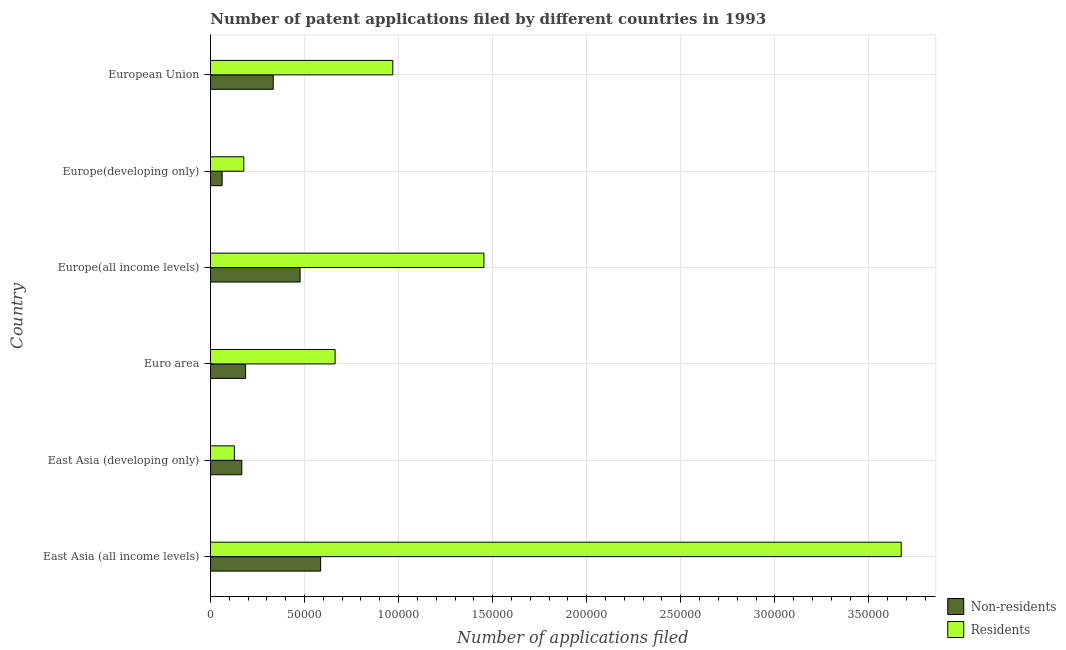How many groups of bars are there?
Ensure brevity in your answer.  6. Are the number of bars on each tick of the Y-axis equal?
Your answer should be very brief. Yes. How many bars are there on the 2nd tick from the top?
Provide a short and direct response. 2. In how many cases, is the number of bars for a given country not equal to the number of legend labels?
Your response must be concise. 0. What is the number of patent applications by non residents in Europe(developing only)?
Your answer should be very brief. 6206. Across all countries, what is the maximum number of patent applications by residents?
Offer a very short reply. 3.67e+05. Across all countries, what is the minimum number of patent applications by residents?
Your response must be concise. 1.27e+04. In which country was the number of patent applications by non residents maximum?
Your response must be concise. East Asia (all income levels). In which country was the number of patent applications by residents minimum?
Offer a very short reply. East Asia (developing only). What is the total number of patent applications by non residents in the graph?
Offer a very short reply. 1.81e+05. What is the difference between the number of patent applications by residents in East Asia (all income levels) and that in Euro area?
Your response must be concise. 3.01e+05. What is the difference between the number of patent applications by residents in East Asia (all income levels) and the number of patent applications by non residents in East Asia (developing only)?
Your response must be concise. 3.51e+05. What is the average number of patent applications by residents per country?
Make the answer very short. 1.18e+05. What is the difference between the number of patent applications by residents and number of patent applications by non residents in Europe(all income levels)?
Your answer should be very brief. 9.77e+04. In how many countries, is the number of patent applications by non residents greater than 360000 ?
Provide a short and direct response. 0. What is the ratio of the number of patent applications by residents in Euro area to that in Europe(all income levels)?
Offer a terse response. 0.46. Is the number of patent applications by residents in East Asia (developing only) less than that in Euro area?
Your answer should be compact. Yes. Is the difference between the number of patent applications by non residents in East Asia (all income levels) and European Union greater than the difference between the number of patent applications by residents in East Asia (all income levels) and European Union?
Offer a terse response. No. What is the difference between the highest and the second highest number of patent applications by residents?
Provide a succinct answer. 2.22e+05. What is the difference between the highest and the lowest number of patent applications by residents?
Provide a short and direct response. 3.54e+05. In how many countries, is the number of patent applications by residents greater than the average number of patent applications by residents taken over all countries?
Offer a terse response. 2. What does the 1st bar from the top in East Asia (all income levels) represents?
Ensure brevity in your answer.  Residents. What does the 2nd bar from the bottom in East Asia (developing only) represents?
Provide a short and direct response. Residents. How many bars are there?
Offer a terse response. 12. How many countries are there in the graph?
Offer a very short reply. 6. What is the difference between two consecutive major ticks on the X-axis?
Give a very brief answer. 5.00e+04. Does the graph contain any zero values?
Your response must be concise. No. Does the graph contain grids?
Provide a short and direct response. Yes. How many legend labels are there?
Your answer should be very brief. 2. What is the title of the graph?
Make the answer very short. Number of patent applications filed by different countries in 1993. Does "US$" appear as one of the legend labels in the graph?
Offer a very short reply. No. What is the label or title of the X-axis?
Provide a short and direct response. Number of applications filed. What is the Number of applications filed of Non-residents in East Asia (all income levels)?
Offer a very short reply. 5.86e+04. What is the Number of applications filed of Residents in East Asia (all income levels)?
Provide a short and direct response. 3.67e+05. What is the Number of applications filed in Non-residents in East Asia (developing only)?
Your response must be concise. 1.67e+04. What is the Number of applications filed in Residents in East Asia (developing only)?
Ensure brevity in your answer.  1.27e+04. What is the Number of applications filed of Non-residents in Euro area?
Offer a terse response. 1.87e+04. What is the Number of applications filed in Residents in Euro area?
Offer a terse response. 6.63e+04. What is the Number of applications filed of Non-residents in Europe(all income levels)?
Keep it short and to the point. 4.76e+04. What is the Number of applications filed of Residents in Europe(all income levels)?
Your response must be concise. 1.45e+05. What is the Number of applications filed in Non-residents in Europe(developing only)?
Your response must be concise. 6206. What is the Number of applications filed of Residents in Europe(developing only)?
Offer a very short reply. 1.77e+04. What is the Number of applications filed in Non-residents in European Union?
Your answer should be compact. 3.34e+04. What is the Number of applications filed in Residents in European Union?
Your answer should be very brief. 9.69e+04. Across all countries, what is the maximum Number of applications filed in Non-residents?
Offer a very short reply. 5.86e+04. Across all countries, what is the maximum Number of applications filed of Residents?
Give a very brief answer. 3.67e+05. Across all countries, what is the minimum Number of applications filed of Non-residents?
Make the answer very short. 6206. Across all countries, what is the minimum Number of applications filed in Residents?
Your answer should be compact. 1.27e+04. What is the total Number of applications filed in Non-residents in the graph?
Provide a short and direct response. 1.81e+05. What is the total Number of applications filed of Residents in the graph?
Your response must be concise. 7.06e+05. What is the difference between the Number of applications filed of Non-residents in East Asia (all income levels) and that in East Asia (developing only)?
Your answer should be compact. 4.19e+04. What is the difference between the Number of applications filed of Residents in East Asia (all income levels) and that in East Asia (developing only)?
Give a very brief answer. 3.54e+05. What is the difference between the Number of applications filed in Non-residents in East Asia (all income levels) and that in Euro area?
Your response must be concise. 3.99e+04. What is the difference between the Number of applications filed in Residents in East Asia (all income levels) and that in Euro area?
Give a very brief answer. 3.01e+05. What is the difference between the Number of applications filed in Non-residents in East Asia (all income levels) and that in Europe(all income levels)?
Ensure brevity in your answer.  1.09e+04. What is the difference between the Number of applications filed in Residents in East Asia (all income levels) and that in Europe(all income levels)?
Offer a very short reply. 2.22e+05. What is the difference between the Number of applications filed of Non-residents in East Asia (all income levels) and that in Europe(developing only)?
Your answer should be compact. 5.24e+04. What is the difference between the Number of applications filed of Residents in East Asia (all income levels) and that in Europe(developing only)?
Your answer should be compact. 3.49e+05. What is the difference between the Number of applications filed of Non-residents in East Asia (all income levels) and that in European Union?
Your response must be concise. 2.52e+04. What is the difference between the Number of applications filed of Residents in East Asia (all income levels) and that in European Union?
Your answer should be compact. 2.70e+05. What is the difference between the Number of applications filed in Non-residents in East Asia (developing only) and that in Euro area?
Your answer should be very brief. -2012. What is the difference between the Number of applications filed of Residents in East Asia (developing only) and that in Euro area?
Keep it short and to the point. -5.36e+04. What is the difference between the Number of applications filed of Non-residents in East Asia (developing only) and that in Europe(all income levels)?
Your answer should be very brief. -3.10e+04. What is the difference between the Number of applications filed of Residents in East Asia (developing only) and that in Europe(all income levels)?
Make the answer very short. -1.33e+05. What is the difference between the Number of applications filed in Non-residents in East Asia (developing only) and that in Europe(developing only)?
Provide a short and direct response. 1.05e+04. What is the difference between the Number of applications filed in Residents in East Asia (developing only) and that in Europe(developing only)?
Give a very brief answer. -5010. What is the difference between the Number of applications filed in Non-residents in East Asia (developing only) and that in European Union?
Give a very brief answer. -1.67e+04. What is the difference between the Number of applications filed in Residents in East Asia (developing only) and that in European Union?
Your response must be concise. -8.42e+04. What is the difference between the Number of applications filed of Non-residents in Euro area and that in Europe(all income levels)?
Your answer should be very brief. -2.90e+04. What is the difference between the Number of applications filed of Residents in Euro area and that in Europe(all income levels)?
Provide a short and direct response. -7.91e+04. What is the difference between the Number of applications filed in Non-residents in Euro area and that in Europe(developing only)?
Provide a short and direct response. 1.25e+04. What is the difference between the Number of applications filed in Residents in Euro area and that in Europe(developing only)?
Offer a very short reply. 4.85e+04. What is the difference between the Number of applications filed in Non-residents in Euro area and that in European Union?
Ensure brevity in your answer.  -1.47e+04. What is the difference between the Number of applications filed in Residents in Euro area and that in European Union?
Your answer should be compact. -3.07e+04. What is the difference between the Number of applications filed in Non-residents in Europe(all income levels) and that in Europe(developing only)?
Your response must be concise. 4.14e+04. What is the difference between the Number of applications filed in Residents in Europe(all income levels) and that in Europe(developing only)?
Keep it short and to the point. 1.28e+05. What is the difference between the Number of applications filed in Non-residents in Europe(all income levels) and that in European Union?
Ensure brevity in your answer.  1.43e+04. What is the difference between the Number of applications filed of Residents in Europe(all income levels) and that in European Union?
Make the answer very short. 4.84e+04. What is the difference between the Number of applications filed of Non-residents in Europe(developing only) and that in European Union?
Offer a very short reply. -2.72e+04. What is the difference between the Number of applications filed in Residents in Europe(developing only) and that in European Union?
Keep it short and to the point. -7.92e+04. What is the difference between the Number of applications filed in Non-residents in East Asia (all income levels) and the Number of applications filed in Residents in East Asia (developing only)?
Your response must be concise. 4.59e+04. What is the difference between the Number of applications filed of Non-residents in East Asia (all income levels) and the Number of applications filed of Residents in Euro area?
Give a very brief answer. -7680. What is the difference between the Number of applications filed of Non-residents in East Asia (all income levels) and the Number of applications filed of Residents in Europe(all income levels)?
Your response must be concise. -8.68e+04. What is the difference between the Number of applications filed of Non-residents in East Asia (all income levels) and the Number of applications filed of Residents in Europe(developing only)?
Your answer should be very brief. 4.09e+04. What is the difference between the Number of applications filed in Non-residents in East Asia (all income levels) and the Number of applications filed in Residents in European Union?
Offer a terse response. -3.83e+04. What is the difference between the Number of applications filed of Non-residents in East Asia (developing only) and the Number of applications filed of Residents in Euro area?
Give a very brief answer. -4.96e+04. What is the difference between the Number of applications filed in Non-residents in East Asia (developing only) and the Number of applications filed in Residents in Europe(all income levels)?
Keep it short and to the point. -1.29e+05. What is the difference between the Number of applications filed in Non-residents in East Asia (developing only) and the Number of applications filed in Residents in Europe(developing only)?
Provide a short and direct response. -1044. What is the difference between the Number of applications filed of Non-residents in East Asia (developing only) and the Number of applications filed of Residents in European Union?
Offer a terse response. -8.03e+04. What is the difference between the Number of applications filed of Non-residents in Euro area and the Number of applications filed of Residents in Europe(all income levels)?
Provide a short and direct response. -1.27e+05. What is the difference between the Number of applications filed of Non-residents in Euro area and the Number of applications filed of Residents in Europe(developing only)?
Provide a short and direct response. 968. What is the difference between the Number of applications filed of Non-residents in Euro area and the Number of applications filed of Residents in European Union?
Your answer should be compact. -7.82e+04. What is the difference between the Number of applications filed in Non-residents in Europe(all income levels) and the Number of applications filed in Residents in Europe(developing only)?
Your response must be concise. 2.99e+04. What is the difference between the Number of applications filed in Non-residents in Europe(all income levels) and the Number of applications filed in Residents in European Union?
Offer a terse response. -4.93e+04. What is the difference between the Number of applications filed of Non-residents in Europe(developing only) and the Number of applications filed of Residents in European Union?
Give a very brief answer. -9.07e+04. What is the average Number of applications filed of Non-residents per country?
Offer a terse response. 3.02e+04. What is the average Number of applications filed of Residents per country?
Your response must be concise. 1.18e+05. What is the difference between the Number of applications filed in Non-residents and Number of applications filed in Residents in East Asia (all income levels)?
Your answer should be very brief. -3.09e+05. What is the difference between the Number of applications filed of Non-residents and Number of applications filed of Residents in East Asia (developing only)?
Your response must be concise. 3966. What is the difference between the Number of applications filed of Non-residents and Number of applications filed of Residents in Euro area?
Offer a terse response. -4.76e+04. What is the difference between the Number of applications filed of Non-residents and Number of applications filed of Residents in Europe(all income levels)?
Ensure brevity in your answer.  -9.77e+04. What is the difference between the Number of applications filed in Non-residents and Number of applications filed in Residents in Europe(developing only)?
Offer a terse response. -1.15e+04. What is the difference between the Number of applications filed in Non-residents and Number of applications filed in Residents in European Union?
Your answer should be very brief. -6.36e+04. What is the ratio of the Number of applications filed of Non-residents in East Asia (all income levels) to that in East Asia (developing only)?
Offer a very short reply. 3.52. What is the ratio of the Number of applications filed in Residents in East Asia (all income levels) to that in East Asia (developing only)?
Your response must be concise. 28.92. What is the ratio of the Number of applications filed in Non-residents in East Asia (all income levels) to that in Euro area?
Offer a terse response. 3.14. What is the ratio of the Number of applications filed of Residents in East Asia (all income levels) to that in Euro area?
Your answer should be very brief. 5.54. What is the ratio of the Number of applications filed of Non-residents in East Asia (all income levels) to that in Europe(all income levels)?
Offer a very short reply. 1.23. What is the ratio of the Number of applications filed in Residents in East Asia (all income levels) to that in Europe(all income levels)?
Your answer should be compact. 2.53. What is the ratio of the Number of applications filed in Non-residents in East Asia (all income levels) to that in Europe(developing only)?
Ensure brevity in your answer.  9.44. What is the ratio of the Number of applications filed of Residents in East Asia (all income levels) to that in Europe(developing only)?
Provide a succinct answer. 20.74. What is the ratio of the Number of applications filed of Non-residents in East Asia (all income levels) to that in European Union?
Your answer should be very brief. 1.76. What is the ratio of the Number of applications filed in Residents in East Asia (all income levels) to that in European Union?
Make the answer very short. 3.79. What is the ratio of the Number of applications filed in Non-residents in East Asia (developing only) to that in Euro area?
Your answer should be very brief. 0.89. What is the ratio of the Number of applications filed in Residents in East Asia (developing only) to that in Euro area?
Your response must be concise. 0.19. What is the ratio of the Number of applications filed in Non-residents in East Asia (developing only) to that in Europe(all income levels)?
Give a very brief answer. 0.35. What is the ratio of the Number of applications filed in Residents in East Asia (developing only) to that in Europe(all income levels)?
Provide a short and direct response. 0.09. What is the ratio of the Number of applications filed of Non-residents in East Asia (developing only) to that in Europe(developing only)?
Give a very brief answer. 2.68. What is the ratio of the Number of applications filed of Residents in East Asia (developing only) to that in Europe(developing only)?
Keep it short and to the point. 0.72. What is the ratio of the Number of applications filed of Non-residents in East Asia (developing only) to that in European Union?
Ensure brevity in your answer.  0.5. What is the ratio of the Number of applications filed in Residents in East Asia (developing only) to that in European Union?
Provide a succinct answer. 0.13. What is the ratio of the Number of applications filed of Non-residents in Euro area to that in Europe(all income levels)?
Provide a succinct answer. 0.39. What is the ratio of the Number of applications filed of Residents in Euro area to that in Europe(all income levels)?
Ensure brevity in your answer.  0.46. What is the ratio of the Number of applications filed in Non-residents in Euro area to that in Europe(developing only)?
Make the answer very short. 3.01. What is the ratio of the Number of applications filed of Residents in Euro area to that in Europe(developing only)?
Ensure brevity in your answer.  3.74. What is the ratio of the Number of applications filed of Non-residents in Euro area to that in European Union?
Give a very brief answer. 0.56. What is the ratio of the Number of applications filed in Residents in Euro area to that in European Union?
Provide a succinct answer. 0.68. What is the ratio of the Number of applications filed in Non-residents in Europe(all income levels) to that in Europe(developing only)?
Provide a short and direct response. 7.68. What is the ratio of the Number of applications filed in Residents in Europe(all income levels) to that in Europe(developing only)?
Provide a succinct answer. 8.21. What is the ratio of the Number of applications filed of Non-residents in Europe(all income levels) to that in European Union?
Provide a succinct answer. 1.43. What is the ratio of the Number of applications filed in Residents in Europe(all income levels) to that in European Union?
Offer a very short reply. 1.5. What is the ratio of the Number of applications filed in Non-residents in Europe(developing only) to that in European Union?
Offer a terse response. 0.19. What is the ratio of the Number of applications filed in Residents in Europe(developing only) to that in European Union?
Provide a short and direct response. 0.18. What is the difference between the highest and the second highest Number of applications filed of Non-residents?
Your answer should be compact. 1.09e+04. What is the difference between the highest and the second highest Number of applications filed in Residents?
Your response must be concise. 2.22e+05. What is the difference between the highest and the lowest Number of applications filed of Non-residents?
Ensure brevity in your answer.  5.24e+04. What is the difference between the highest and the lowest Number of applications filed in Residents?
Your answer should be very brief. 3.54e+05. 